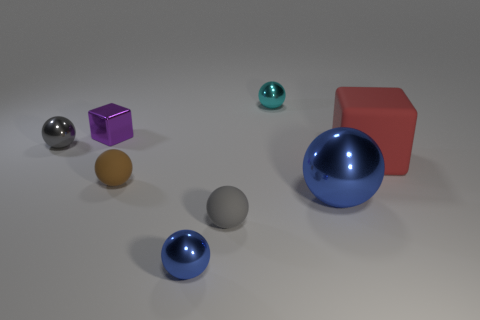Is the number of big things that are behind the large shiny sphere greater than the number of large green metal balls?
Offer a terse response. Yes. Is there anything else that has the same color as the tiny metallic cube?
Offer a terse response. No. The big thing that is made of the same material as the tiny brown thing is what shape?
Make the answer very short. Cube. Is the blue ball left of the cyan sphere made of the same material as the big sphere?
Offer a very short reply. Yes. There is a metal object that is the same color as the big ball; what shape is it?
Offer a terse response. Sphere. Is the color of the tiny rubber ball to the right of the tiny blue metal object the same as the small shiny sphere left of the brown sphere?
Offer a very short reply. Yes. How many metallic spheres are right of the tiny cyan sphere and in front of the small gray matte object?
Your response must be concise. 0. What is the tiny brown object made of?
Make the answer very short. Rubber. There is a brown rubber object that is the same size as the cyan shiny object; what is its shape?
Your answer should be compact. Sphere. Does the tiny gray object that is behind the large red rubber object have the same material as the cube on the right side of the gray matte sphere?
Offer a very short reply. No. 